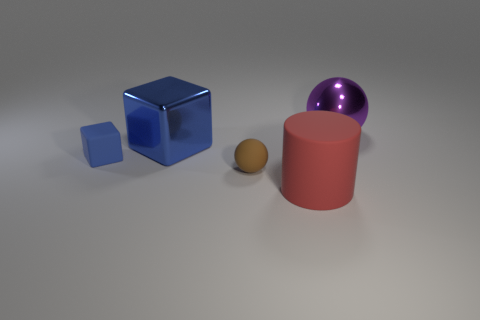Add 2 large brown cubes. How many objects exist? 7 Subtract all yellow cubes. Subtract all gray balls. How many cubes are left? 2 Subtract all cyan cubes. How many blue cylinders are left? 0 Subtract all green metal blocks. Subtract all big purple objects. How many objects are left? 4 Add 3 brown matte objects. How many brown matte objects are left? 4 Add 4 big purple shiny things. How many big purple shiny things exist? 5 Subtract all brown balls. How many balls are left? 1 Subtract 0 cyan blocks. How many objects are left? 5 Subtract all balls. How many objects are left? 3 